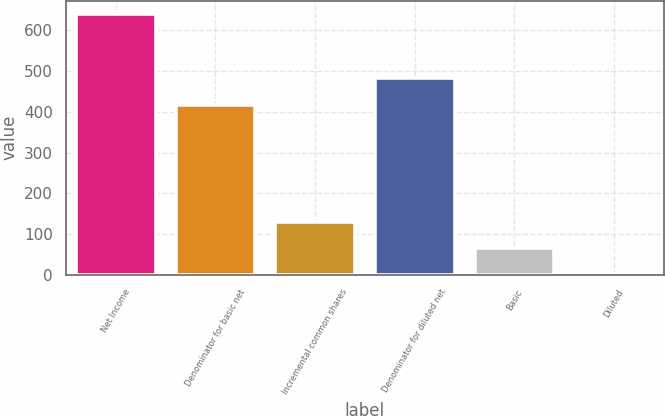<chart> <loc_0><loc_0><loc_500><loc_500><bar_chart><fcel>Net Income<fcel>Denominator for basic net<fcel>Incremental common shares<fcel>Denominator for diluted net<fcel>Basic<fcel>Diluted<nl><fcel>641<fcel>418<fcel>129.28<fcel>481.96<fcel>65.32<fcel>1.36<nl></chart> 